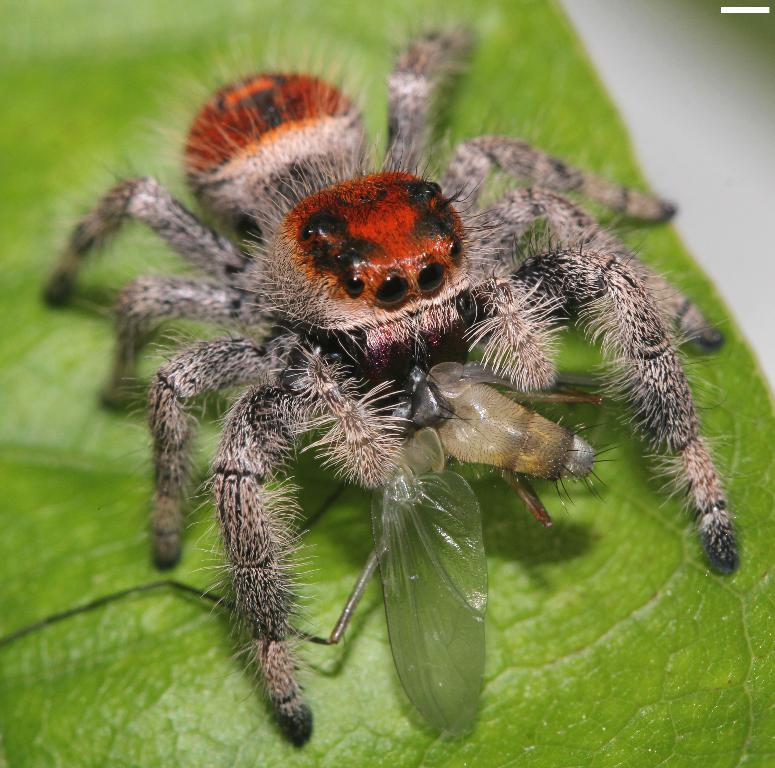What type of creature is present in the image? There is a spider in the image. What other type of creature can be seen in the image? There is an insect in the image. Where are the spider and the insect located in the image? Both the spider and the insect are on a leaf. What type of business is being conducted by the spider and the insect in the image? There is no indication of any business being conducted in the image; it simply features a spider and an insect on a leaf. 